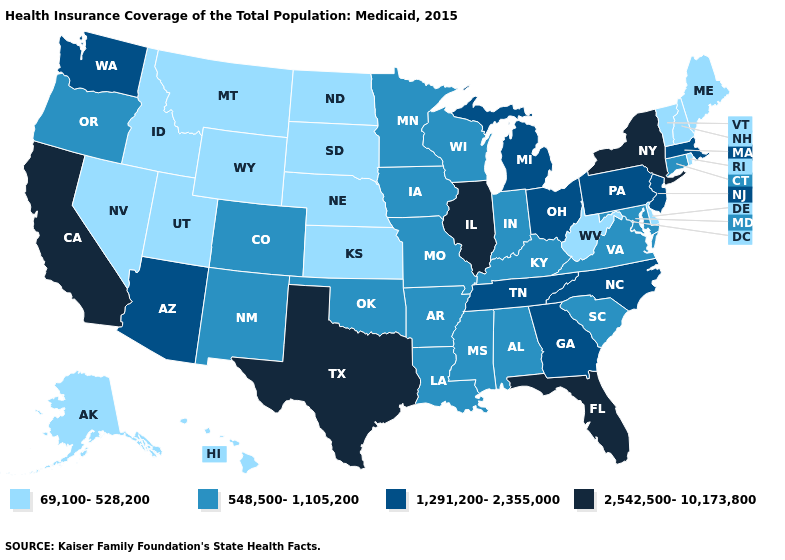Among the states that border Washington , which have the lowest value?
Be succinct. Idaho. What is the value of Tennessee?
Quick response, please. 1,291,200-2,355,000. Which states have the lowest value in the South?
Keep it brief. Delaware, West Virginia. What is the value of Iowa?
Keep it brief. 548,500-1,105,200. What is the lowest value in states that border Arizona?
Keep it brief. 69,100-528,200. Does Missouri have the highest value in the MidWest?
Be succinct. No. Among the states that border Iowa , does Illinois have the highest value?
Quick response, please. Yes. Name the states that have a value in the range 1,291,200-2,355,000?
Give a very brief answer. Arizona, Georgia, Massachusetts, Michigan, New Jersey, North Carolina, Ohio, Pennsylvania, Tennessee, Washington. Does Colorado have a lower value than Alabama?
Quick response, please. No. Name the states that have a value in the range 69,100-528,200?
Be succinct. Alaska, Delaware, Hawaii, Idaho, Kansas, Maine, Montana, Nebraska, Nevada, New Hampshire, North Dakota, Rhode Island, South Dakota, Utah, Vermont, West Virginia, Wyoming. Which states have the lowest value in the USA?
Be succinct. Alaska, Delaware, Hawaii, Idaho, Kansas, Maine, Montana, Nebraska, Nevada, New Hampshire, North Dakota, Rhode Island, South Dakota, Utah, Vermont, West Virginia, Wyoming. What is the value of Louisiana?
Be succinct. 548,500-1,105,200. What is the value of Georgia?
Quick response, please. 1,291,200-2,355,000. Name the states that have a value in the range 1,291,200-2,355,000?
Concise answer only. Arizona, Georgia, Massachusetts, Michigan, New Jersey, North Carolina, Ohio, Pennsylvania, Tennessee, Washington. What is the lowest value in the MidWest?
Answer briefly. 69,100-528,200. 